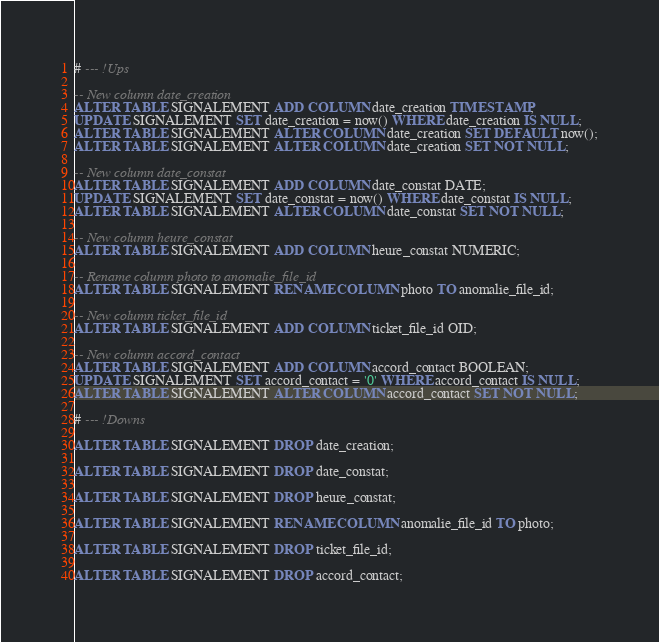<code> <loc_0><loc_0><loc_500><loc_500><_SQL_># --- !Ups

-- New column date_creation
ALTER TABLE SIGNALEMENT ADD COLUMN date_creation TIMESTAMP;
UPDATE SIGNALEMENT SET date_creation = now() WHERE date_creation IS NULL;
ALTER TABLE SIGNALEMENT ALTER COLUMN date_creation SET DEFAULT now();
ALTER TABLE SIGNALEMENT ALTER COLUMN date_creation SET NOT NULL;

-- New column date_constat
ALTER TABLE SIGNALEMENT ADD COLUMN date_constat DATE;
UPDATE SIGNALEMENT SET date_constat = now() WHERE date_constat IS NULL;
ALTER TABLE SIGNALEMENT ALTER COLUMN date_constat SET NOT NULL;

-- New column heure_constat
ALTER TABLE SIGNALEMENT ADD COLUMN heure_constat NUMERIC;

-- Rename column photo to anomalie_file_id
ALTER TABLE SIGNALEMENT RENAME COLUMN photo TO anomalie_file_id;

-- New column ticket_file_id
ALTER TABLE SIGNALEMENT ADD COLUMN ticket_file_id OID;

-- New column accord_contact
ALTER TABLE SIGNALEMENT ADD COLUMN accord_contact BOOLEAN;
UPDATE SIGNALEMENT SET accord_contact = '0' WHERE accord_contact IS NULL;
ALTER TABLE SIGNALEMENT ALTER COLUMN accord_contact SET NOT NULL;

# --- !Downs

ALTER TABLE SIGNALEMENT DROP date_creation;

ALTER TABLE SIGNALEMENT DROP date_constat;

ALTER TABLE SIGNALEMENT DROP heure_constat;

ALTER TABLE SIGNALEMENT RENAME COLUMN anomalie_file_id TO photo;

ALTER TABLE SIGNALEMENT DROP ticket_file_id;

ALTER TABLE SIGNALEMENT DROP accord_contact;</code> 